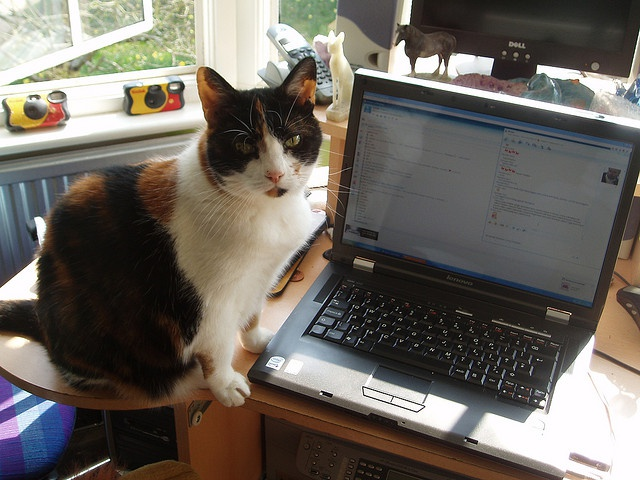Describe the objects in this image and their specific colors. I can see laptop in ivory, gray, black, white, and darkgray tones, cat in ivory, black, gray, and tan tones, tv in ivory, black, and white tones, horse in ivory, black, and gray tones, and mouse in ivory, black, gray, and maroon tones in this image. 